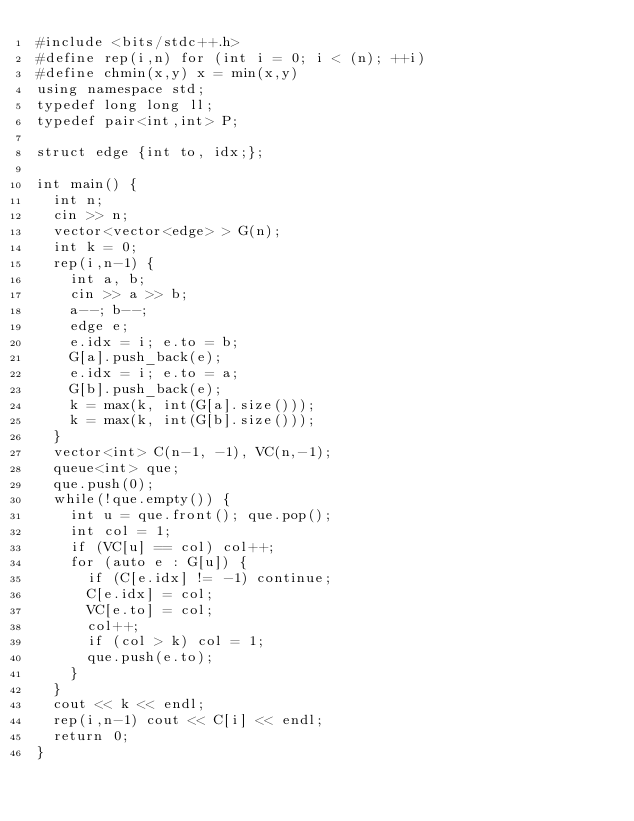<code> <loc_0><loc_0><loc_500><loc_500><_C++_>#include <bits/stdc++.h>
#define rep(i,n) for (int i = 0; i < (n); ++i)
#define chmin(x,y) x = min(x,y)
using namespace std;
typedef long long ll;
typedef pair<int,int> P;

struct edge {int to, idx;};

int main() {
  int n;
  cin >> n;
  vector<vector<edge> > G(n);
  int k = 0;
  rep(i,n-1) {
    int a, b;
    cin >> a >> b;
    a--; b--;
    edge e;
    e.idx = i; e.to = b;
    G[a].push_back(e);
    e.idx = i; e.to = a;
    G[b].push_back(e);
    k = max(k, int(G[a].size()));
    k = max(k, int(G[b].size()));
  }
  vector<int> C(n-1, -1), VC(n,-1);
  queue<int> que;
  que.push(0);
  while(!que.empty()) {
    int u = que.front(); que.pop();
    int col = 1;
    if (VC[u] == col) col++;
    for (auto e : G[u]) {
      if (C[e.idx] != -1) continue;
      C[e.idx] = col;
      VC[e.to] = col;
      col++;
      if (col > k) col = 1;
      que.push(e.to);
    }
  }
  cout << k << endl;
  rep(i,n-1) cout << C[i] << endl;
  return 0;
}</code> 